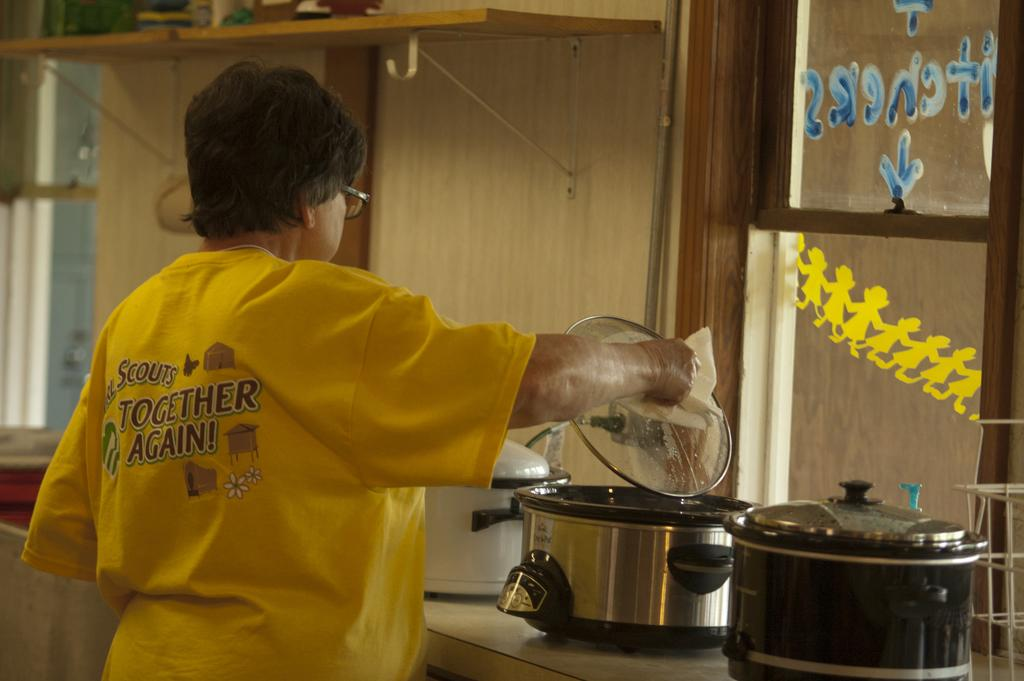<image>
Share a concise interpretation of the image provided. A woman is in the kitchen and wearing a shirt that says "together again!" on the back. 